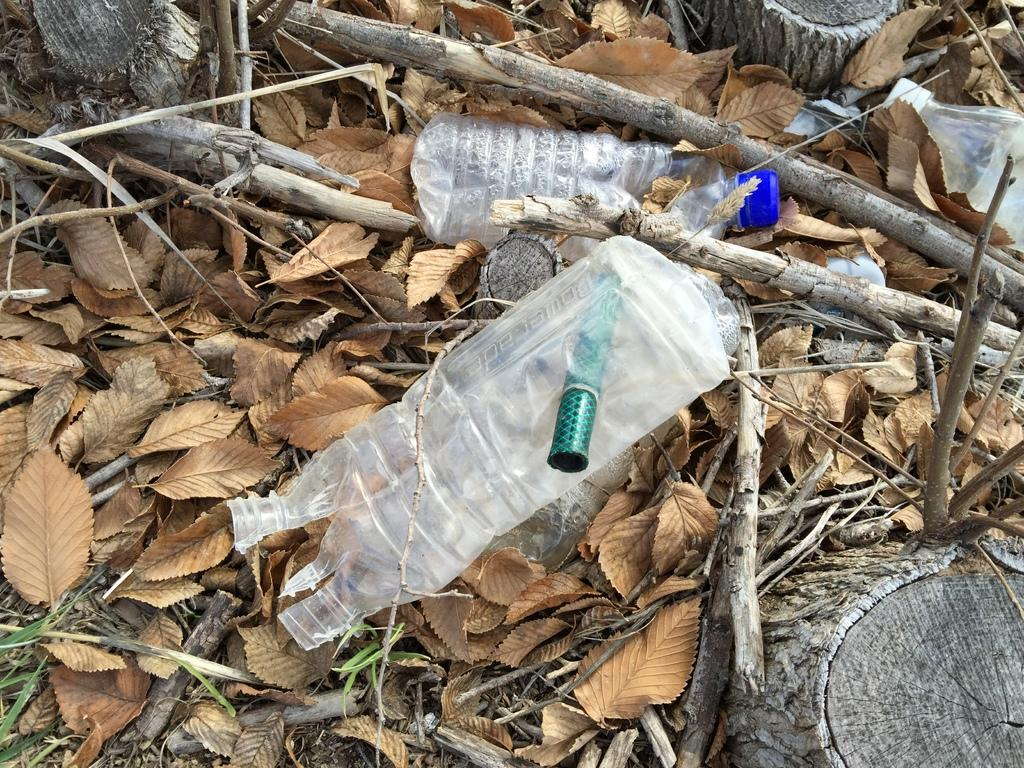What type of plant parts can be seen in the image? There are leaves, stems, and trunks in the image. What man-made objects are present in the image? There is a plastic bottle and a plastic pipe in the image. What type of quill can be seen in the image? There is no quill present in the image. How many quinces are visible in the image? There are no quinces present in the image. 